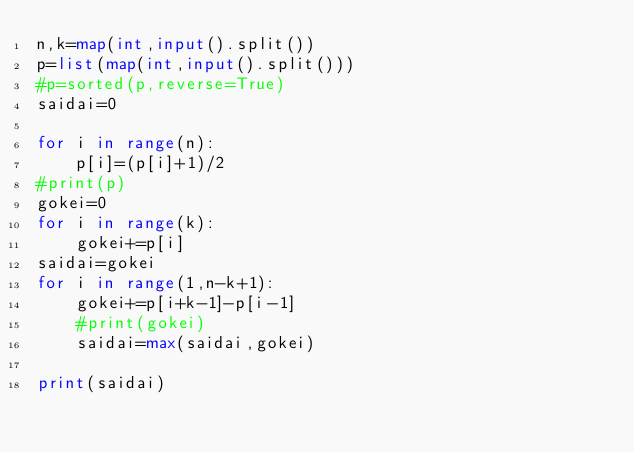Convert code to text. <code><loc_0><loc_0><loc_500><loc_500><_Python_>n,k=map(int,input().split())
p=list(map(int,input().split()))
#p=sorted(p,reverse=True)
saidai=0

for i in range(n):
    p[i]=(p[i]+1)/2
#print(p)
gokei=0
for i in range(k):
    gokei+=p[i]
saidai=gokei
for i in range(1,n-k+1):
    gokei+=p[i+k-1]-p[i-1]
    #print(gokei)
    saidai=max(saidai,gokei)

print(saidai)
</code> 